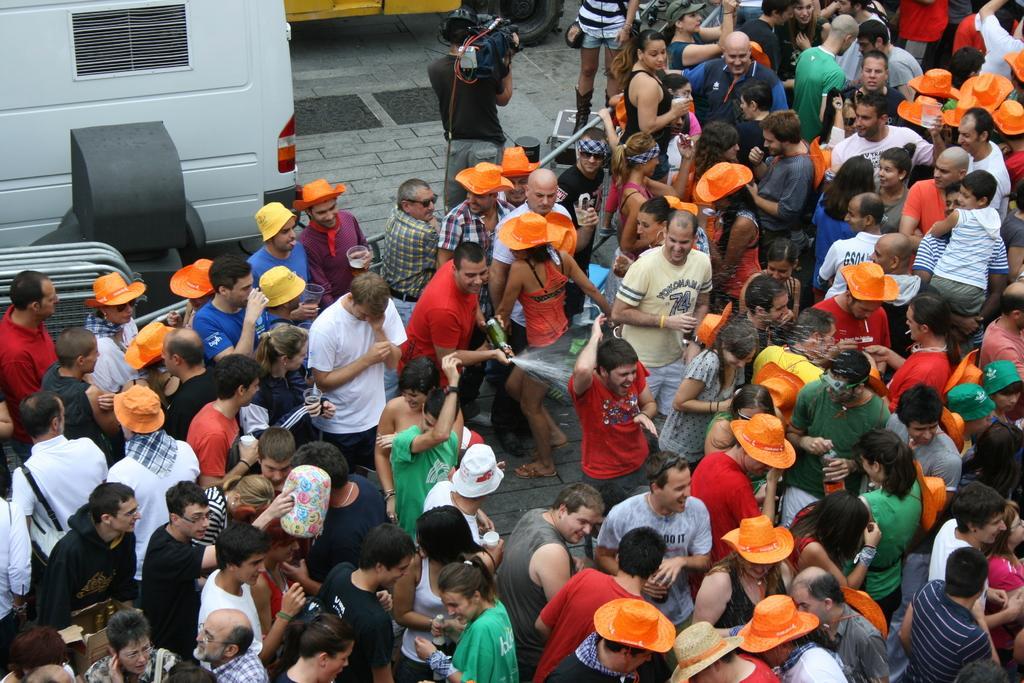Can you describe this image briefly? In this image I can see group of people among them some are holding objects in hands. Some are holding yellow and orange color hats. Here I can see a vehicle and other objects on the ground. 